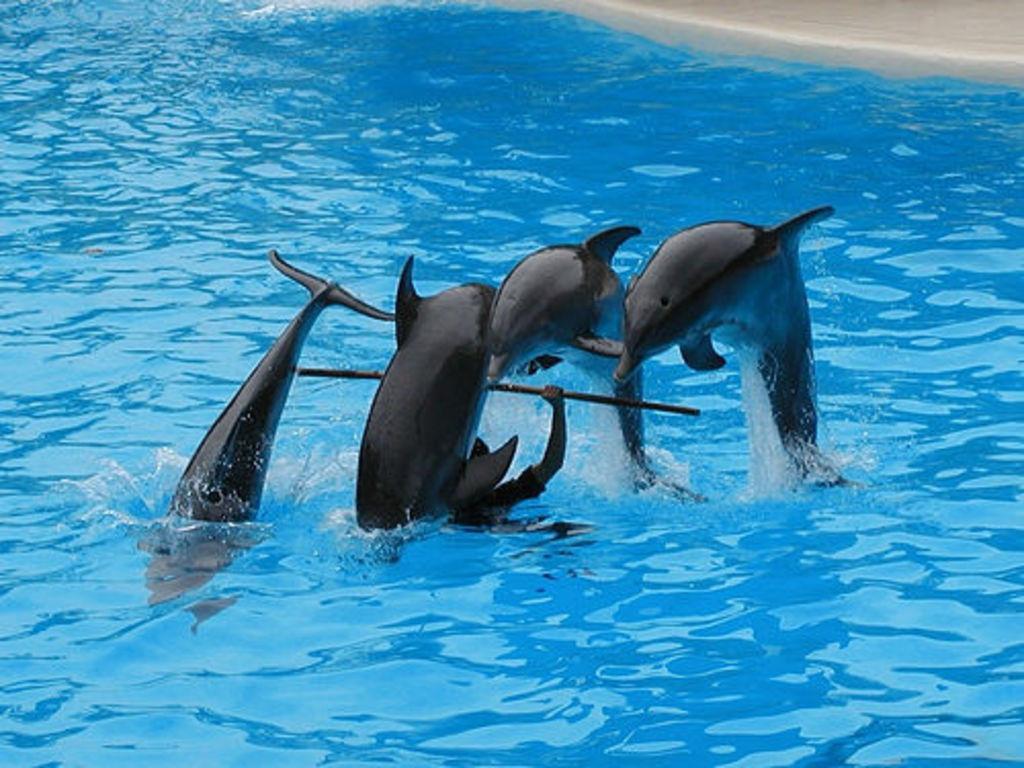Please provide a concise description of this image. In this picture there is a person holding an object and we can see dolphins and water. 